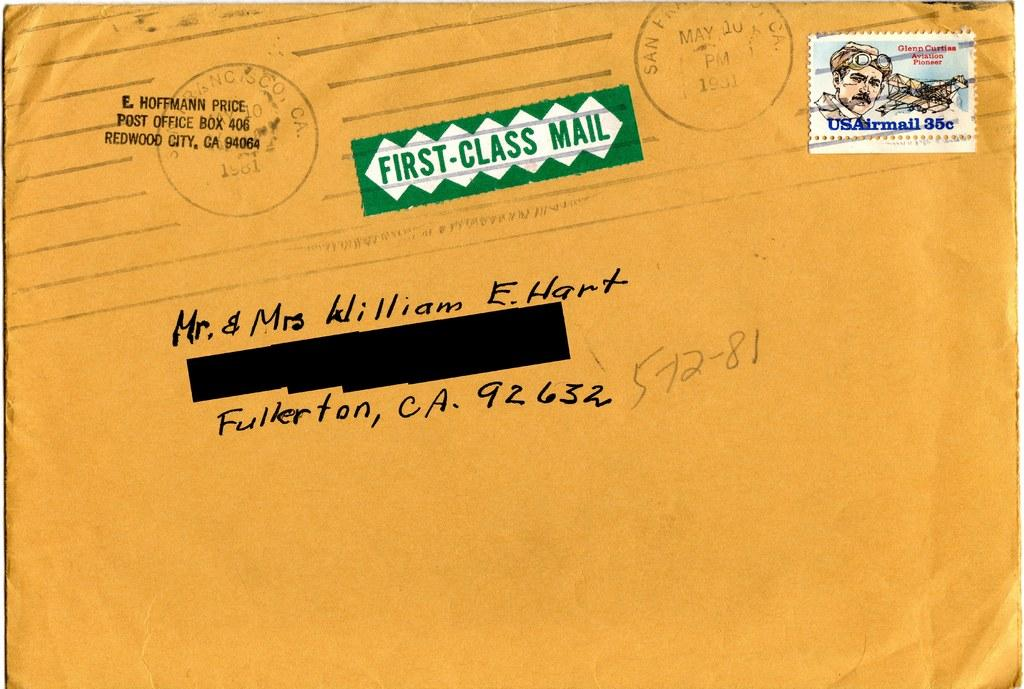Provide a one-sentence caption for the provided image. The envelope is going to travel  to Fullerton, California. 